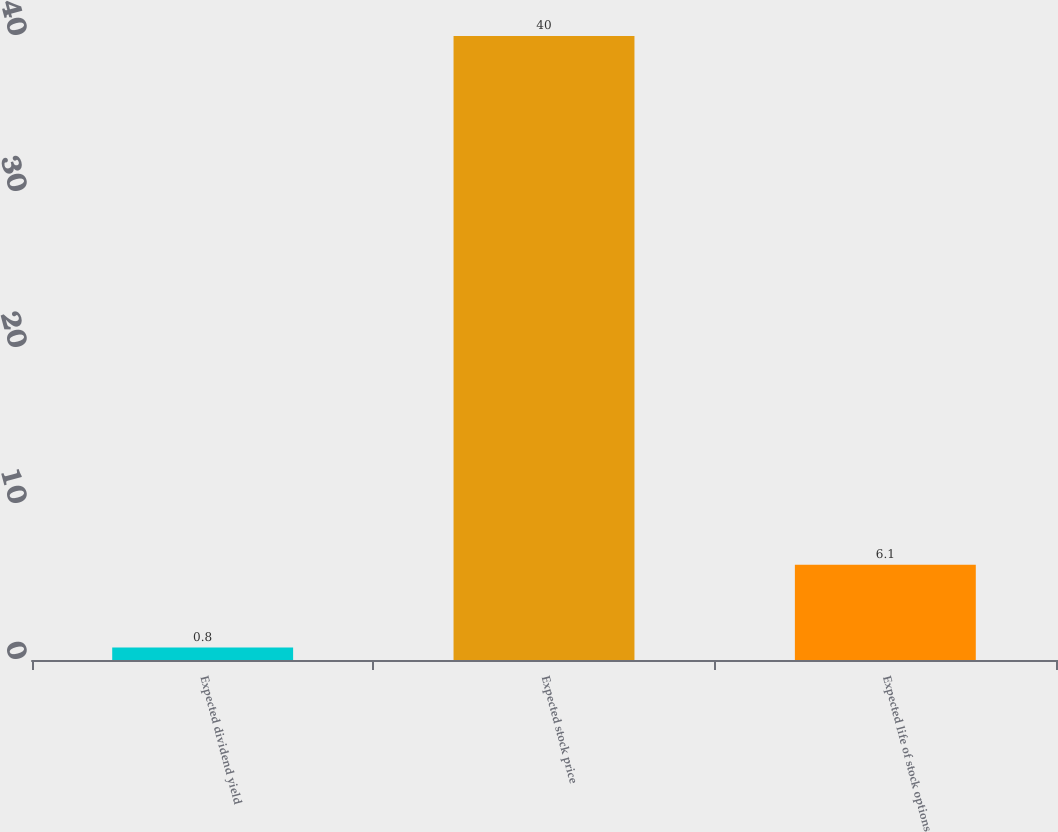<chart> <loc_0><loc_0><loc_500><loc_500><bar_chart><fcel>Expected dividend yield<fcel>Expected stock price<fcel>Expected life of stock options<nl><fcel>0.8<fcel>40<fcel>6.1<nl></chart> 